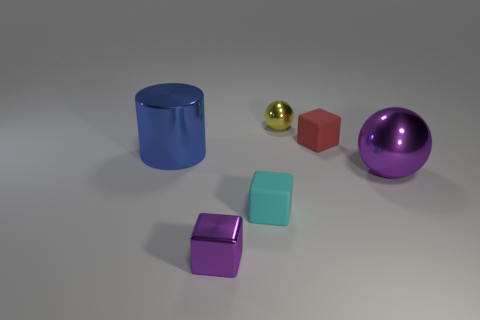Subtract all small matte cubes. How many cubes are left? 1 Add 1 big shiny cylinders. How many objects exist? 7 Subtract all red blocks. How many blocks are left? 2 Subtract all spheres. How many objects are left? 4 Subtract all red rubber things. Subtract all tiny metallic cubes. How many objects are left? 4 Add 6 yellow balls. How many yellow balls are left? 7 Add 2 tiny cyan matte objects. How many tiny cyan matte objects exist? 3 Subtract 0 green cylinders. How many objects are left? 6 Subtract all purple spheres. Subtract all purple cubes. How many spheres are left? 1 